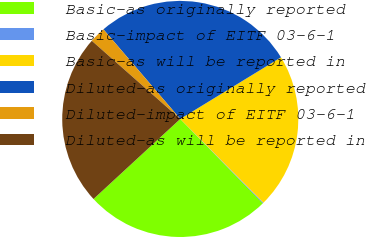Convert chart to OTSL. <chart><loc_0><loc_0><loc_500><loc_500><pie_chart><fcel>Basic-as originally reported<fcel>Basic-impact of EITF 03-6-1<fcel>Basic-as will be reported in<fcel>Diluted-as originally reported<fcel>Diluted-impact of EITF 03-6-1<fcel>Diluted-as will be reported in<nl><fcel>25.47%<fcel>0.11%<fcel>21.3%<fcel>27.55%<fcel>2.2%<fcel>23.38%<nl></chart> 